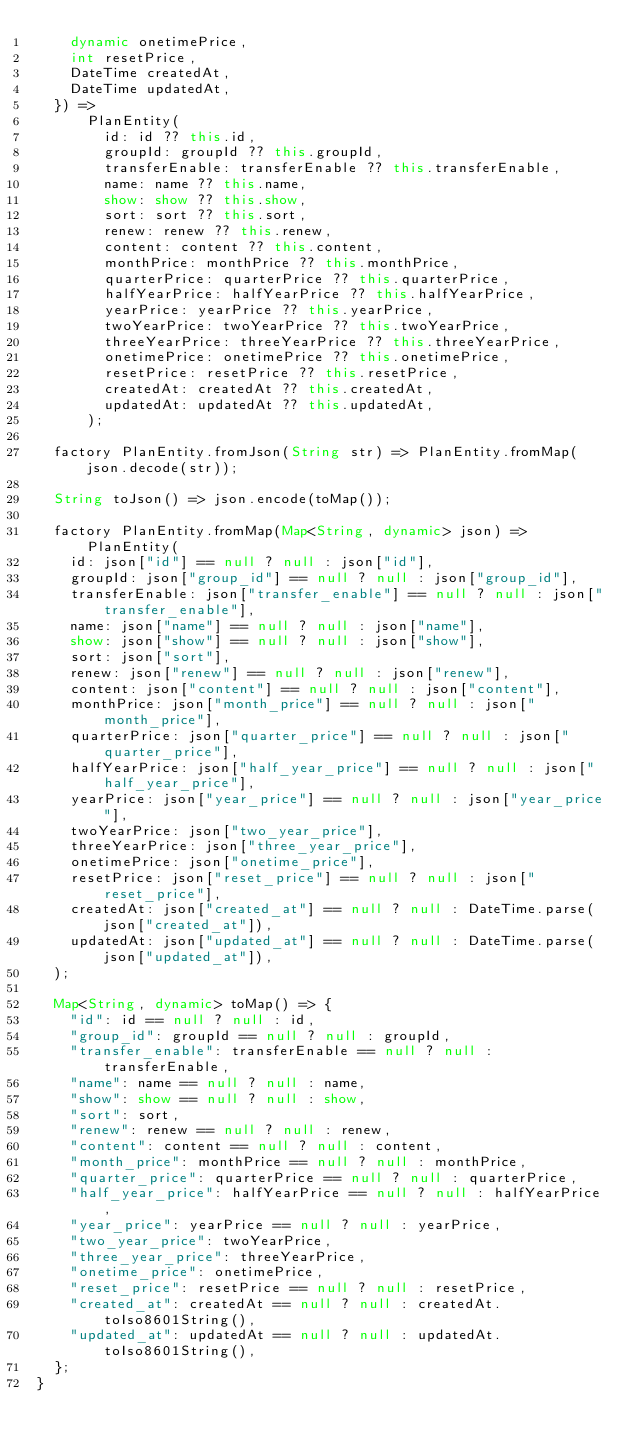Convert code to text. <code><loc_0><loc_0><loc_500><loc_500><_Dart_>    dynamic onetimePrice,
    int resetPrice,
    DateTime createdAt,
    DateTime updatedAt,
  }) =>
      PlanEntity(
        id: id ?? this.id,
        groupId: groupId ?? this.groupId,
        transferEnable: transferEnable ?? this.transferEnable,
        name: name ?? this.name,
        show: show ?? this.show,
        sort: sort ?? this.sort,
        renew: renew ?? this.renew,
        content: content ?? this.content,
        monthPrice: monthPrice ?? this.monthPrice,
        quarterPrice: quarterPrice ?? this.quarterPrice,
        halfYearPrice: halfYearPrice ?? this.halfYearPrice,
        yearPrice: yearPrice ?? this.yearPrice,
        twoYearPrice: twoYearPrice ?? this.twoYearPrice,
        threeYearPrice: threeYearPrice ?? this.threeYearPrice,
        onetimePrice: onetimePrice ?? this.onetimePrice,
        resetPrice: resetPrice ?? this.resetPrice,
        createdAt: createdAt ?? this.createdAt,
        updatedAt: updatedAt ?? this.updatedAt,
      );

  factory PlanEntity.fromJson(String str) => PlanEntity.fromMap(json.decode(str));

  String toJson() => json.encode(toMap());

  factory PlanEntity.fromMap(Map<String, dynamic> json) => PlanEntity(
    id: json["id"] == null ? null : json["id"],
    groupId: json["group_id"] == null ? null : json["group_id"],
    transferEnable: json["transfer_enable"] == null ? null : json["transfer_enable"],
    name: json["name"] == null ? null : json["name"],
    show: json["show"] == null ? null : json["show"],
    sort: json["sort"],
    renew: json["renew"] == null ? null : json["renew"],
    content: json["content"] == null ? null : json["content"],
    monthPrice: json["month_price"] == null ? null : json["month_price"],
    quarterPrice: json["quarter_price"] == null ? null : json["quarter_price"],
    halfYearPrice: json["half_year_price"] == null ? null : json["half_year_price"],
    yearPrice: json["year_price"] == null ? null : json["year_price"],
    twoYearPrice: json["two_year_price"],
    threeYearPrice: json["three_year_price"],
    onetimePrice: json["onetime_price"],
    resetPrice: json["reset_price"] == null ? null : json["reset_price"],
    createdAt: json["created_at"] == null ? null : DateTime.parse(json["created_at"]),
    updatedAt: json["updated_at"] == null ? null : DateTime.parse(json["updated_at"]),
  );

  Map<String, dynamic> toMap() => {
    "id": id == null ? null : id,
    "group_id": groupId == null ? null : groupId,
    "transfer_enable": transferEnable == null ? null : transferEnable,
    "name": name == null ? null : name,
    "show": show == null ? null : show,
    "sort": sort,
    "renew": renew == null ? null : renew,
    "content": content == null ? null : content,
    "month_price": monthPrice == null ? null : monthPrice,
    "quarter_price": quarterPrice == null ? null : quarterPrice,
    "half_year_price": halfYearPrice == null ? null : halfYearPrice,
    "year_price": yearPrice == null ? null : yearPrice,
    "two_year_price": twoYearPrice,
    "three_year_price": threeYearPrice,
    "onetime_price": onetimePrice,
    "reset_price": resetPrice == null ? null : resetPrice,
    "created_at": createdAt == null ? null : createdAt.toIso8601String(),
    "updated_at": updatedAt == null ? null : updatedAt.toIso8601String(),
  };
}
</code> 